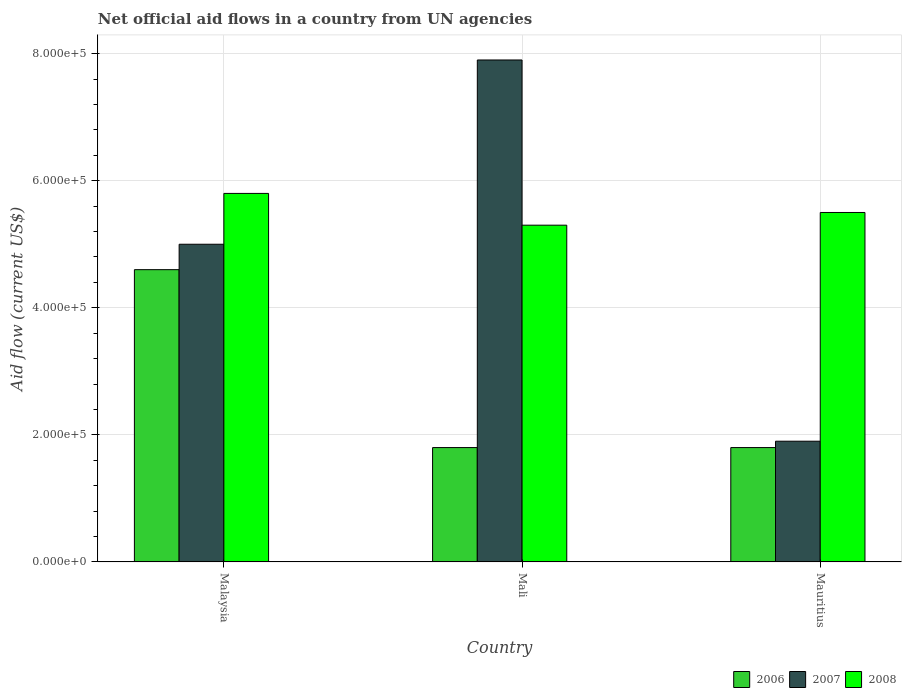What is the label of the 1st group of bars from the left?
Keep it short and to the point. Malaysia. In how many cases, is the number of bars for a given country not equal to the number of legend labels?
Make the answer very short. 0. What is the net official aid flow in 2007 in Mauritius?
Offer a very short reply. 1.90e+05. Across all countries, what is the maximum net official aid flow in 2008?
Your response must be concise. 5.80e+05. Across all countries, what is the minimum net official aid flow in 2008?
Offer a terse response. 5.30e+05. In which country was the net official aid flow in 2007 maximum?
Make the answer very short. Mali. In which country was the net official aid flow in 2007 minimum?
Your answer should be very brief. Mauritius. What is the total net official aid flow in 2006 in the graph?
Make the answer very short. 8.20e+05. What is the difference between the net official aid flow in 2007 in Malaysia and that in Mauritius?
Provide a succinct answer. 3.10e+05. What is the difference between the net official aid flow in 2006 in Mali and the net official aid flow in 2008 in Mauritius?
Your response must be concise. -3.70e+05. What is the average net official aid flow in 2008 per country?
Ensure brevity in your answer.  5.53e+05. In how many countries, is the net official aid flow in 2008 greater than 560000 US$?
Provide a short and direct response. 1. What is the ratio of the net official aid flow in 2007 in Malaysia to that in Mauritius?
Your response must be concise. 2.63. Is the net official aid flow in 2006 in Mali less than that in Mauritius?
Your answer should be very brief. No. Is the difference between the net official aid flow in 2007 in Malaysia and Mauritius greater than the difference between the net official aid flow in 2006 in Malaysia and Mauritius?
Ensure brevity in your answer.  Yes. What is the difference between the highest and the second highest net official aid flow in 2006?
Offer a terse response. 2.80e+05. Is the sum of the net official aid flow in 2007 in Malaysia and Mauritius greater than the maximum net official aid flow in 2008 across all countries?
Make the answer very short. Yes. What does the 3rd bar from the left in Mauritius represents?
Keep it short and to the point. 2008. What does the 2nd bar from the right in Mauritius represents?
Provide a short and direct response. 2007. How many bars are there?
Offer a terse response. 9. Are all the bars in the graph horizontal?
Your answer should be very brief. No. What is the difference between two consecutive major ticks on the Y-axis?
Offer a very short reply. 2.00e+05. Does the graph contain grids?
Make the answer very short. Yes. Where does the legend appear in the graph?
Ensure brevity in your answer.  Bottom right. What is the title of the graph?
Give a very brief answer. Net official aid flows in a country from UN agencies. What is the label or title of the Y-axis?
Your answer should be very brief. Aid flow (current US$). What is the Aid flow (current US$) of 2007 in Malaysia?
Ensure brevity in your answer.  5.00e+05. What is the Aid flow (current US$) of 2008 in Malaysia?
Your answer should be compact. 5.80e+05. What is the Aid flow (current US$) in 2007 in Mali?
Offer a terse response. 7.90e+05. What is the Aid flow (current US$) in 2008 in Mali?
Your answer should be very brief. 5.30e+05. Across all countries, what is the maximum Aid flow (current US$) of 2006?
Ensure brevity in your answer.  4.60e+05. Across all countries, what is the maximum Aid flow (current US$) of 2007?
Provide a succinct answer. 7.90e+05. Across all countries, what is the maximum Aid flow (current US$) of 2008?
Keep it short and to the point. 5.80e+05. Across all countries, what is the minimum Aid flow (current US$) of 2008?
Your answer should be compact. 5.30e+05. What is the total Aid flow (current US$) of 2006 in the graph?
Your response must be concise. 8.20e+05. What is the total Aid flow (current US$) of 2007 in the graph?
Provide a short and direct response. 1.48e+06. What is the total Aid flow (current US$) in 2008 in the graph?
Offer a terse response. 1.66e+06. What is the difference between the Aid flow (current US$) in 2006 in Malaysia and that in Mauritius?
Ensure brevity in your answer.  2.80e+05. What is the difference between the Aid flow (current US$) in 2008 in Malaysia and that in Mauritius?
Keep it short and to the point. 3.00e+04. What is the difference between the Aid flow (current US$) of 2007 in Mali and that in Mauritius?
Provide a short and direct response. 6.00e+05. What is the difference between the Aid flow (current US$) of 2008 in Mali and that in Mauritius?
Provide a succinct answer. -2.00e+04. What is the difference between the Aid flow (current US$) in 2006 in Malaysia and the Aid flow (current US$) in 2007 in Mali?
Ensure brevity in your answer.  -3.30e+05. What is the difference between the Aid flow (current US$) in 2007 in Malaysia and the Aid flow (current US$) in 2008 in Mauritius?
Give a very brief answer. -5.00e+04. What is the difference between the Aid flow (current US$) of 2006 in Mali and the Aid flow (current US$) of 2008 in Mauritius?
Offer a very short reply. -3.70e+05. What is the average Aid flow (current US$) of 2006 per country?
Offer a very short reply. 2.73e+05. What is the average Aid flow (current US$) of 2007 per country?
Your response must be concise. 4.93e+05. What is the average Aid flow (current US$) in 2008 per country?
Offer a very short reply. 5.53e+05. What is the difference between the Aid flow (current US$) in 2006 and Aid flow (current US$) in 2008 in Malaysia?
Offer a very short reply. -1.20e+05. What is the difference between the Aid flow (current US$) of 2006 and Aid flow (current US$) of 2007 in Mali?
Give a very brief answer. -6.10e+05. What is the difference between the Aid flow (current US$) of 2006 and Aid flow (current US$) of 2008 in Mali?
Offer a terse response. -3.50e+05. What is the difference between the Aid flow (current US$) of 2006 and Aid flow (current US$) of 2008 in Mauritius?
Make the answer very short. -3.70e+05. What is the difference between the Aid flow (current US$) in 2007 and Aid flow (current US$) in 2008 in Mauritius?
Your response must be concise. -3.60e+05. What is the ratio of the Aid flow (current US$) of 2006 in Malaysia to that in Mali?
Offer a terse response. 2.56. What is the ratio of the Aid flow (current US$) of 2007 in Malaysia to that in Mali?
Ensure brevity in your answer.  0.63. What is the ratio of the Aid flow (current US$) of 2008 in Malaysia to that in Mali?
Ensure brevity in your answer.  1.09. What is the ratio of the Aid flow (current US$) in 2006 in Malaysia to that in Mauritius?
Your answer should be very brief. 2.56. What is the ratio of the Aid flow (current US$) of 2007 in Malaysia to that in Mauritius?
Offer a very short reply. 2.63. What is the ratio of the Aid flow (current US$) in 2008 in Malaysia to that in Mauritius?
Your response must be concise. 1.05. What is the ratio of the Aid flow (current US$) of 2006 in Mali to that in Mauritius?
Ensure brevity in your answer.  1. What is the ratio of the Aid flow (current US$) in 2007 in Mali to that in Mauritius?
Give a very brief answer. 4.16. What is the ratio of the Aid flow (current US$) in 2008 in Mali to that in Mauritius?
Give a very brief answer. 0.96. What is the difference between the highest and the second highest Aid flow (current US$) in 2008?
Keep it short and to the point. 3.00e+04. What is the difference between the highest and the lowest Aid flow (current US$) of 2006?
Your answer should be very brief. 2.80e+05. 